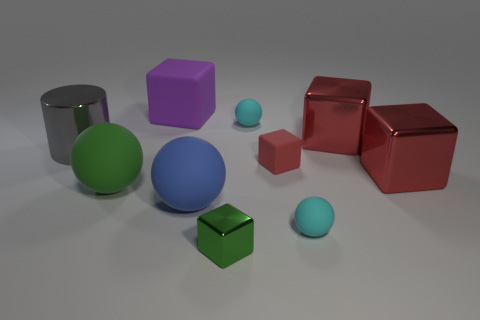Subtract all purple balls. How many red cubes are left? 3 Subtract 1 cubes. How many cubes are left? 4 Subtract all gray blocks. Subtract all brown balls. How many blocks are left? 5 Subtract all balls. How many objects are left? 6 Add 7 tiny purple rubber objects. How many tiny purple rubber objects exist? 7 Subtract 0 green cylinders. How many objects are left? 10 Subtract all large red spheres. Subtract all red cubes. How many objects are left? 7 Add 8 big gray shiny things. How many big gray shiny things are left? 9 